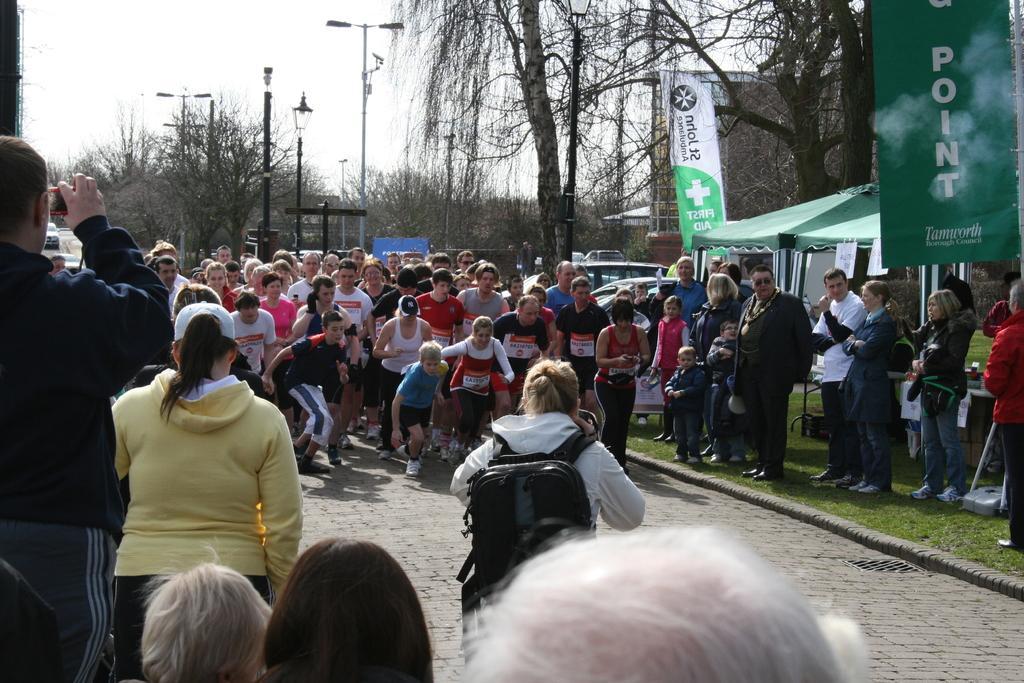Could you give a brief overview of what you see in this image? In this picture we can see a group of people where some are running on the road and some are standing on grass, banners, tents, trees, poles, vehicles and in the background we can see the sky. 